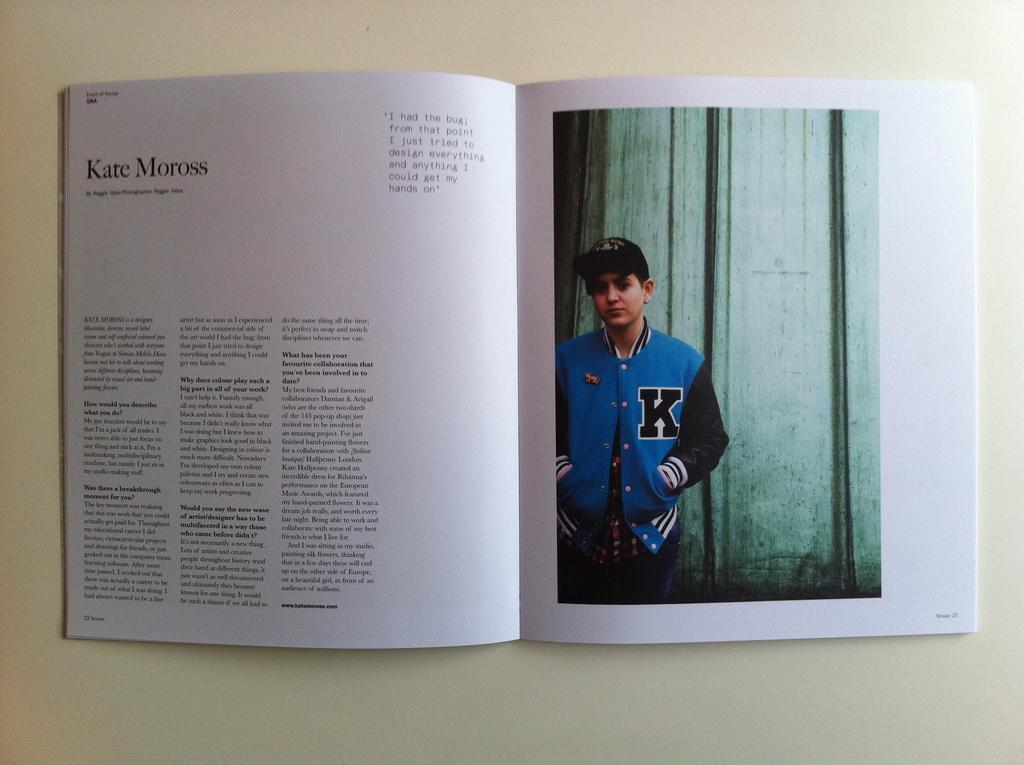<image>
Offer a succinct explanation of the picture presented. A book is open to a story about Kate Moross and a photograph of a person in a blue jacket. 